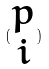Convert formula to latex. <formula><loc_0><loc_0><loc_500><loc_500>( \begin{matrix} p \\ i \end{matrix} )</formula> 